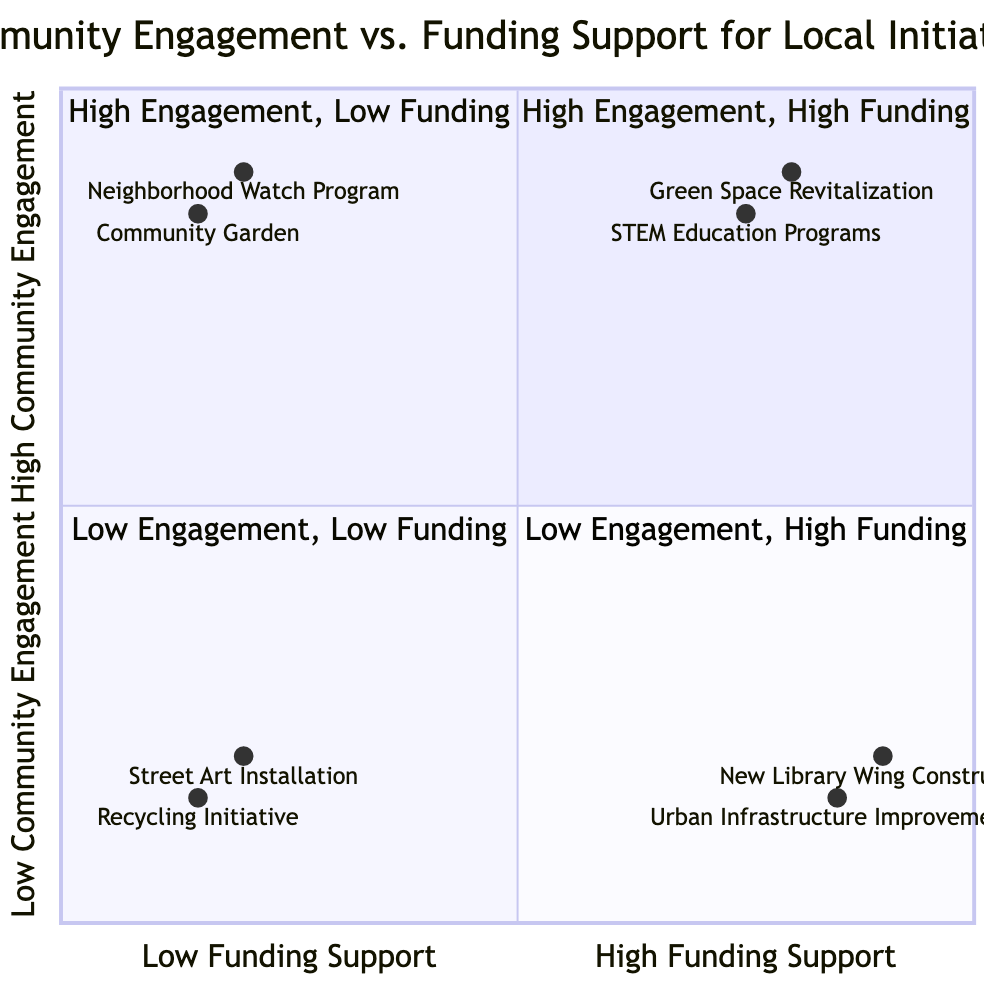What projects are in the High Community Engagement and High Funding Support quadrant? The High Community Engagement and High Funding Support quadrant includes projects that involve substantial community participation and receive significant financial support. According to the data, these projects are "Green Space Revitalization" and "STEM Education Programs."
Answer: Green Space Revitalization, STEM Education Programs How many projects are categorized under Low Community Engagement and Low Funding Support? The Low Community Engagement and Low Funding Support quadrant consists of projects that have both minimal community participation and little financial investment. There are two projects listed in this category, which are "Street Art Installation" and "Recycling Initiative."
Answer: 2 Which project has the lowest community engagement? To determine the project with the lowest community engagement, we examine the projects in the Low Community Engagement quadrants, focusing on their engagement levels. The projects "Street Art Installation" and "Recycling Initiative" have the same low engagement, with the lowest scores recorded being 0.2 and 0.15, respectively. "Street Art Installation" has the lowest overall engagement score of 0.2.
Answer: Street Art Installation What is the funding support level for the Neighborhood Watch Program? The Neighborhood Watch Program is positioned at a low funding support level within the quadrant, with coordinates indicating a funding support value of 0.2. This means that the financial backing for this initiative is minimal.
Answer: Low Are there any projects with high funding support that lack community engagement? By analyzing the Low Community Engagement and High Funding Support quadrant, we find projects that have significant funding but little local participation. The projects identified are "New Library Wing Construction" and "Urban Infrastructure Improvements," indicating that high funding support does not correlate with community engagement in these cases.
Answer: Yes, two projects Which quadrant has the most projects listed? Upon reviewing the quadrants for the number of projects, it becomes evident that the High Community Engagement and Low Funding Support quadrant contains four projects. Therefore, this quadrant has the most projects compared to the others, which have fewer.
Answer: High Community Engagement, Low Funding Support What are the engagement levels for the projects in the Low Community Engagement quadrant? In the Low Community Engagement quadrants, the projects are categorized as follows: "New Library Wing Construction" has an engagement score of 0.2, "Urban Infrastructure Improvements" has 0.15, "Street Art Installation" has 0.2, and "Recycling Initiative" has 0.15. Thus, the scores indicate a very low level of engagement across all projects in this category.
Answer: 0.2, 0.15, 0.2, 0.15 Identify one project with high funding support and community involvement. The High Community Engagement and High Funding Support quadrant features projects characterized by both strong community involvement and significant financial resources. A notable example is "STEM Education Programs," which reflects this dual high standing.
Answer: STEM Education Programs 